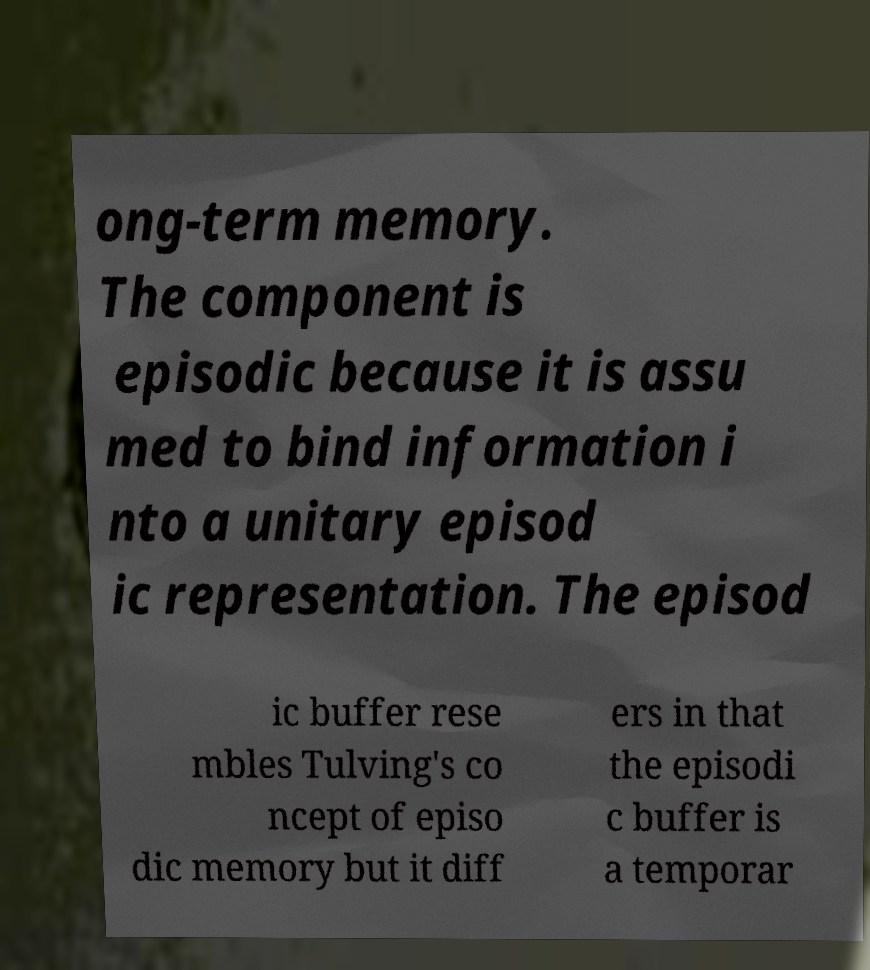Could you assist in decoding the text presented in this image and type it out clearly? ong-term memory. The component is episodic because it is assu med to bind information i nto a unitary episod ic representation. The episod ic buffer rese mbles Tulving's co ncept of episo dic memory but it diff ers in that the episodi c buffer is a temporar 